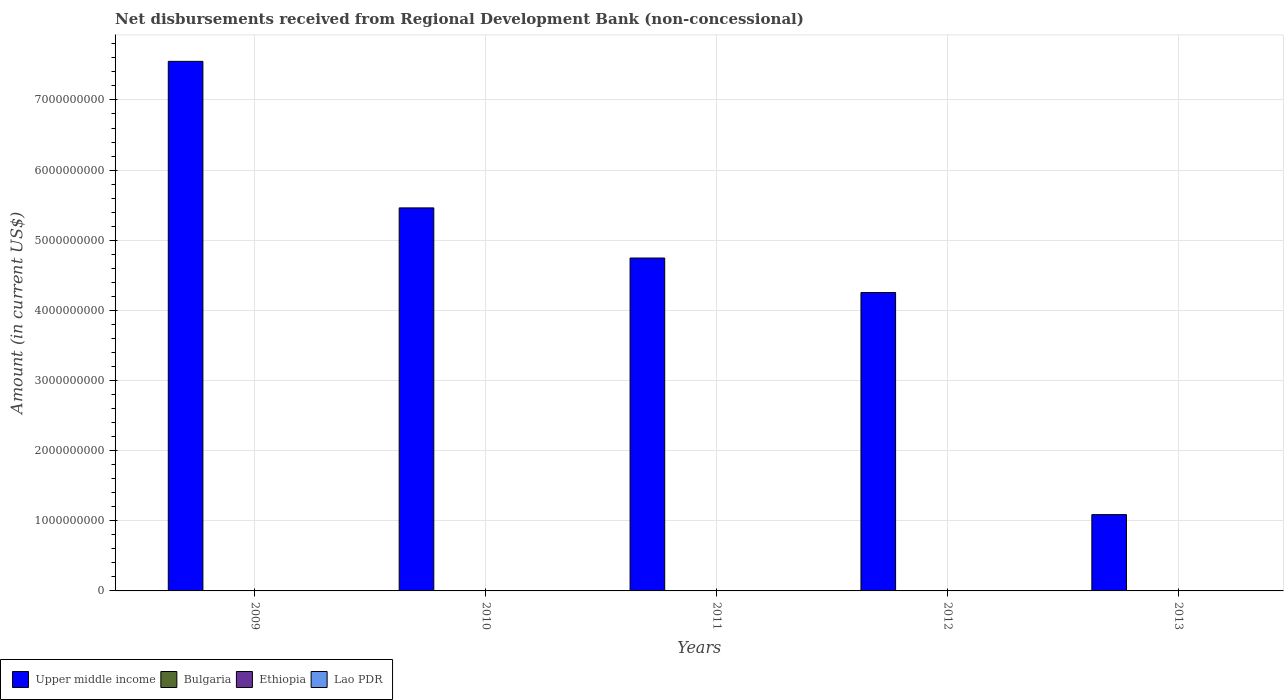Are the number of bars per tick equal to the number of legend labels?
Your answer should be very brief. No. How many bars are there on the 4th tick from the left?
Your answer should be very brief. 1. In how many cases, is the number of bars for a given year not equal to the number of legend labels?
Provide a succinct answer. 5. What is the amount of disbursements received from Regional Development Bank in Ethiopia in 2010?
Offer a terse response. 0. Across all years, what is the maximum amount of disbursements received from Regional Development Bank in Lao PDR?
Your answer should be compact. 4.51e+05. Across all years, what is the minimum amount of disbursements received from Regional Development Bank in Ethiopia?
Ensure brevity in your answer.  0. In which year was the amount of disbursements received from Regional Development Bank in Upper middle income maximum?
Your answer should be compact. 2009. What is the difference between the amount of disbursements received from Regional Development Bank in Upper middle income in 2009 and that in 2012?
Your response must be concise. 3.30e+09. What is the difference between the amount of disbursements received from Regional Development Bank in Lao PDR in 2010 and the amount of disbursements received from Regional Development Bank in Upper middle income in 2009?
Keep it short and to the point. -7.55e+09. What is the average amount of disbursements received from Regional Development Bank in Lao PDR per year?
Your answer should be compact. 1.21e+05. In the year 2009, what is the difference between the amount of disbursements received from Regional Development Bank in Upper middle income and amount of disbursements received from Regional Development Bank in Lao PDR?
Provide a short and direct response. 7.55e+09. In how many years, is the amount of disbursements received from Regional Development Bank in Upper middle income greater than 400000000 US$?
Ensure brevity in your answer.  5. What is the ratio of the amount of disbursements received from Regional Development Bank in Upper middle income in 2009 to that in 2010?
Give a very brief answer. 1.38. What is the difference between the highest and the lowest amount of disbursements received from Regional Development Bank in Lao PDR?
Your response must be concise. 4.51e+05. How many bars are there?
Your response must be concise. 7. Are all the bars in the graph horizontal?
Ensure brevity in your answer.  No. Are the values on the major ticks of Y-axis written in scientific E-notation?
Make the answer very short. No. Does the graph contain any zero values?
Your answer should be compact. Yes. Does the graph contain grids?
Give a very brief answer. Yes. How many legend labels are there?
Keep it short and to the point. 4. What is the title of the graph?
Your answer should be very brief. Net disbursements received from Regional Development Bank (non-concessional). What is the label or title of the X-axis?
Make the answer very short. Years. What is the label or title of the Y-axis?
Keep it short and to the point. Amount (in current US$). What is the Amount (in current US$) of Upper middle income in 2009?
Give a very brief answer. 7.55e+09. What is the Amount (in current US$) of Bulgaria in 2009?
Offer a very short reply. 0. What is the Amount (in current US$) of Ethiopia in 2009?
Ensure brevity in your answer.  0. What is the Amount (in current US$) in Lao PDR in 2009?
Your response must be concise. 4.51e+05. What is the Amount (in current US$) of Upper middle income in 2010?
Offer a terse response. 5.46e+09. What is the Amount (in current US$) in Bulgaria in 2010?
Keep it short and to the point. 0. What is the Amount (in current US$) of Lao PDR in 2010?
Provide a succinct answer. 1.52e+05. What is the Amount (in current US$) in Upper middle income in 2011?
Make the answer very short. 4.75e+09. What is the Amount (in current US$) in Bulgaria in 2011?
Make the answer very short. 0. What is the Amount (in current US$) of Lao PDR in 2011?
Offer a terse response. 0. What is the Amount (in current US$) in Upper middle income in 2012?
Make the answer very short. 4.25e+09. What is the Amount (in current US$) in Bulgaria in 2012?
Offer a terse response. 0. What is the Amount (in current US$) in Upper middle income in 2013?
Provide a succinct answer. 1.09e+09. What is the Amount (in current US$) in Ethiopia in 2013?
Ensure brevity in your answer.  0. What is the Amount (in current US$) of Lao PDR in 2013?
Provide a short and direct response. 0. Across all years, what is the maximum Amount (in current US$) of Upper middle income?
Provide a short and direct response. 7.55e+09. Across all years, what is the maximum Amount (in current US$) in Lao PDR?
Provide a short and direct response. 4.51e+05. Across all years, what is the minimum Amount (in current US$) in Upper middle income?
Provide a succinct answer. 1.09e+09. Across all years, what is the minimum Amount (in current US$) of Lao PDR?
Make the answer very short. 0. What is the total Amount (in current US$) of Upper middle income in the graph?
Ensure brevity in your answer.  2.31e+1. What is the total Amount (in current US$) of Lao PDR in the graph?
Give a very brief answer. 6.03e+05. What is the difference between the Amount (in current US$) of Upper middle income in 2009 and that in 2010?
Your answer should be very brief. 2.09e+09. What is the difference between the Amount (in current US$) of Lao PDR in 2009 and that in 2010?
Your response must be concise. 2.99e+05. What is the difference between the Amount (in current US$) in Upper middle income in 2009 and that in 2011?
Provide a succinct answer. 2.80e+09. What is the difference between the Amount (in current US$) of Upper middle income in 2009 and that in 2012?
Offer a very short reply. 3.30e+09. What is the difference between the Amount (in current US$) in Upper middle income in 2009 and that in 2013?
Your answer should be compact. 6.46e+09. What is the difference between the Amount (in current US$) in Upper middle income in 2010 and that in 2011?
Make the answer very short. 7.15e+08. What is the difference between the Amount (in current US$) in Upper middle income in 2010 and that in 2012?
Your answer should be very brief. 1.21e+09. What is the difference between the Amount (in current US$) in Upper middle income in 2010 and that in 2013?
Offer a very short reply. 4.37e+09. What is the difference between the Amount (in current US$) in Upper middle income in 2011 and that in 2012?
Provide a succinct answer. 4.92e+08. What is the difference between the Amount (in current US$) of Upper middle income in 2011 and that in 2013?
Your response must be concise. 3.66e+09. What is the difference between the Amount (in current US$) in Upper middle income in 2012 and that in 2013?
Your answer should be very brief. 3.17e+09. What is the difference between the Amount (in current US$) in Upper middle income in 2009 and the Amount (in current US$) in Lao PDR in 2010?
Your answer should be compact. 7.55e+09. What is the average Amount (in current US$) of Upper middle income per year?
Your answer should be compact. 4.62e+09. What is the average Amount (in current US$) of Bulgaria per year?
Your answer should be compact. 0. What is the average Amount (in current US$) in Lao PDR per year?
Make the answer very short. 1.21e+05. In the year 2009, what is the difference between the Amount (in current US$) of Upper middle income and Amount (in current US$) of Lao PDR?
Ensure brevity in your answer.  7.55e+09. In the year 2010, what is the difference between the Amount (in current US$) of Upper middle income and Amount (in current US$) of Lao PDR?
Keep it short and to the point. 5.46e+09. What is the ratio of the Amount (in current US$) of Upper middle income in 2009 to that in 2010?
Ensure brevity in your answer.  1.38. What is the ratio of the Amount (in current US$) of Lao PDR in 2009 to that in 2010?
Offer a terse response. 2.97. What is the ratio of the Amount (in current US$) in Upper middle income in 2009 to that in 2011?
Make the answer very short. 1.59. What is the ratio of the Amount (in current US$) in Upper middle income in 2009 to that in 2012?
Give a very brief answer. 1.77. What is the ratio of the Amount (in current US$) in Upper middle income in 2009 to that in 2013?
Provide a succinct answer. 6.94. What is the ratio of the Amount (in current US$) in Upper middle income in 2010 to that in 2011?
Your answer should be compact. 1.15. What is the ratio of the Amount (in current US$) of Upper middle income in 2010 to that in 2012?
Give a very brief answer. 1.28. What is the ratio of the Amount (in current US$) of Upper middle income in 2010 to that in 2013?
Ensure brevity in your answer.  5.02. What is the ratio of the Amount (in current US$) in Upper middle income in 2011 to that in 2012?
Your answer should be compact. 1.12. What is the ratio of the Amount (in current US$) of Upper middle income in 2011 to that in 2013?
Provide a succinct answer. 4.36. What is the ratio of the Amount (in current US$) of Upper middle income in 2012 to that in 2013?
Offer a very short reply. 3.91. What is the difference between the highest and the second highest Amount (in current US$) of Upper middle income?
Provide a succinct answer. 2.09e+09. What is the difference between the highest and the lowest Amount (in current US$) of Upper middle income?
Your answer should be very brief. 6.46e+09. What is the difference between the highest and the lowest Amount (in current US$) of Lao PDR?
Provide a short and direct response. 4.51e+05. 